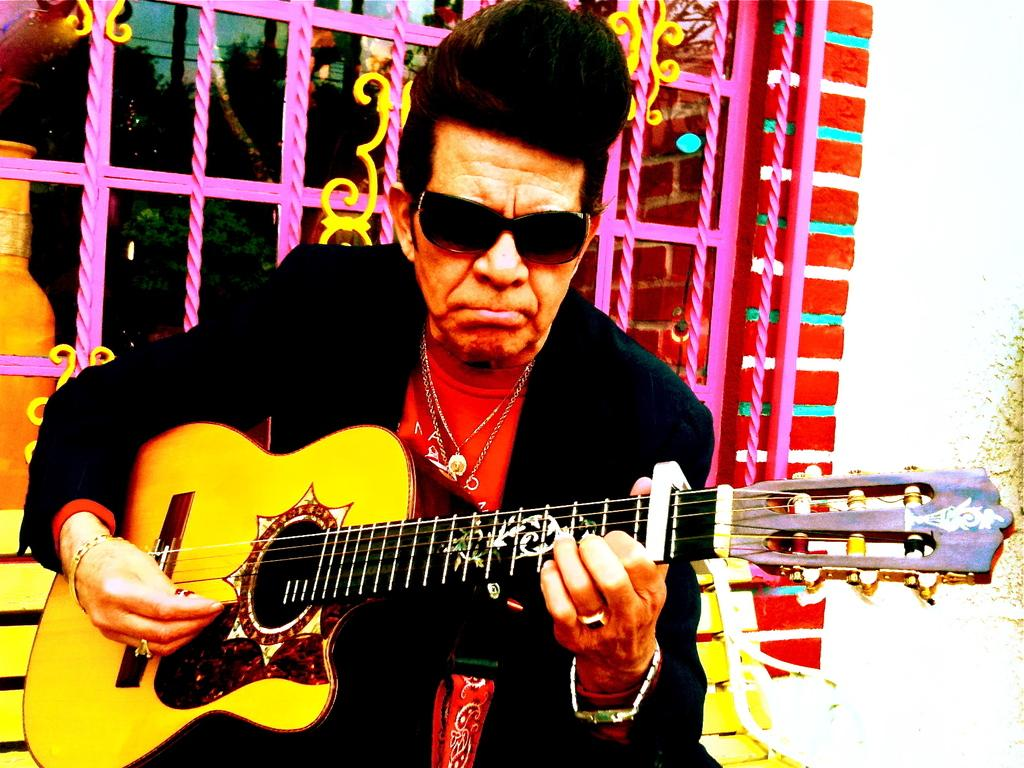What is the person in the image doing? The person is holding a guitar. What can be seen in the background of the image? There is a window and trees visible in the background of the image. What type of tooth is visible in the image? There is no tooth visible in the image. What boundary is present in the image? There is no boundary present in the image. 